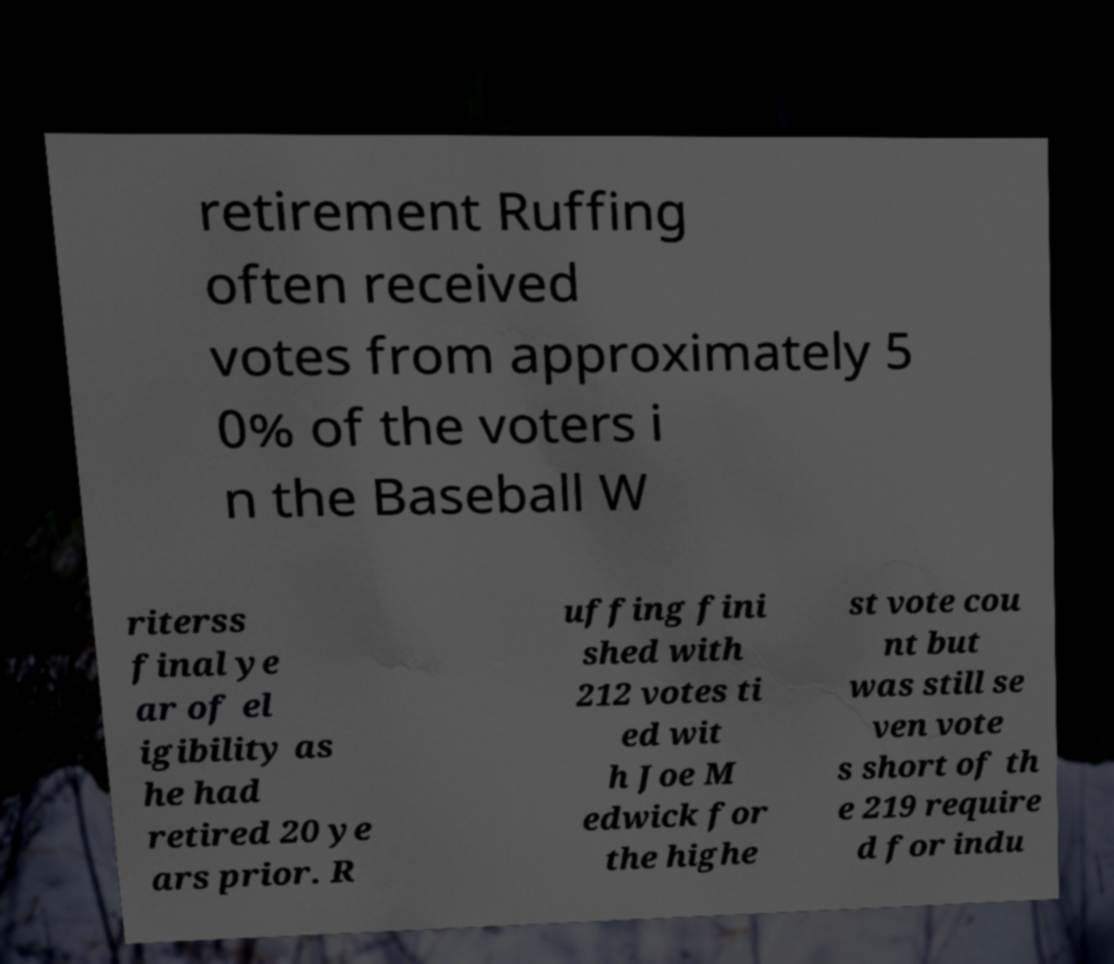What messages or text are displayed in this image? I need them in a readable, typed format. retirement Ruffing often received votes from approximately 5 0% of the voters i n the Baseball W riterss final ye ar of el igibility as he had retired 20 ye ars prior. R uffing fini shed with 212 votes ti ed wit h Joe M edwick for the highe st vote cou nt but was still se ven vote s short of th e 219 require d for indu 